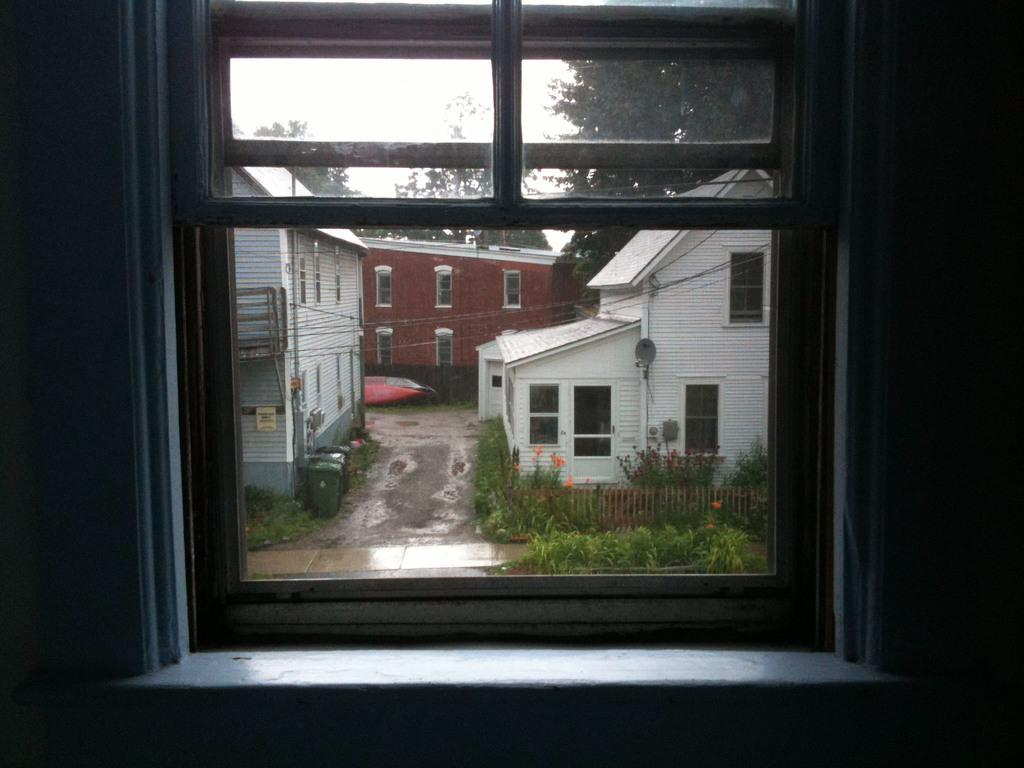What can be seen through the window in the image? There are sheds, trees, bins, and a fence visible through the window in the image. Can you describe the type of structures visible through the window? The structures visible through the window are sheds. What type of vegetation can be seen through the window? Trees can be seen through the window. What type of man-made objects are visible through the window? Bins and a fence are visible through the window. How does the fork make the room quieter in the image? There is no fork present in the image, and therefore it cannot affect the room's quietness. 